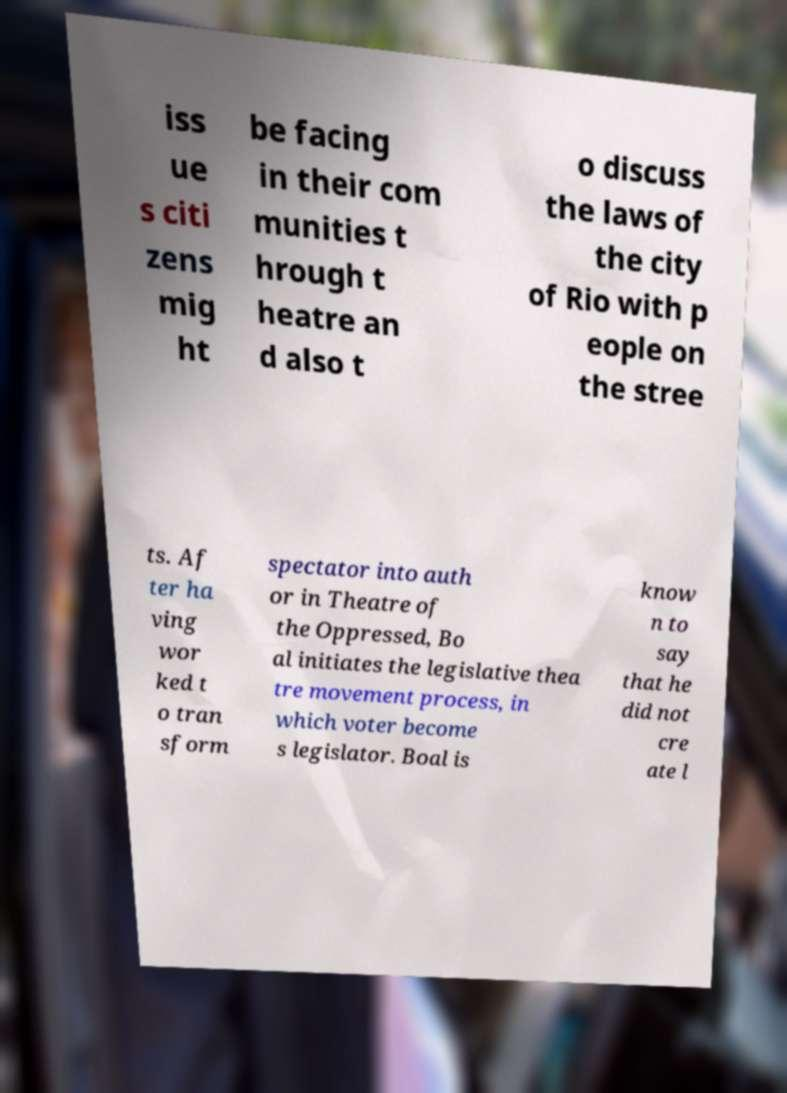What messages or text are displayed in this image? I need them in a readable, typed format. iss ue s citi zens mig ht be facing in their com munities t hrough t heatre an d also t o discuss the laws of the city of Rio with p eople on the stree ts. Af ter ha ving wor ked t o tran sform spectator into auth or in Theatre of the Oppressed, Bo al initiates the legislative thea tre movement process, in which voter become s legislator. Boal is know n to say that he did not cre ate l 